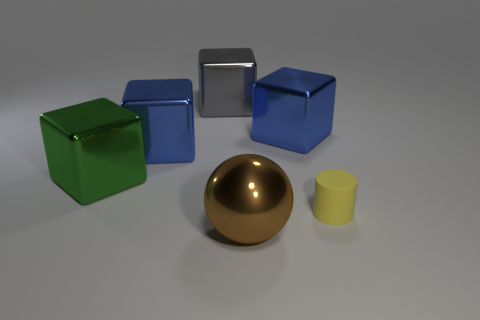Is there a tiny red thing that has the same shape as the green thing? Upon examining the image closely, it appears that there isn’t a tiny red object that matches the shape of the green cube. The items present feature a variety of colors such as green, blue, and golden, along with a silver object and a smaller yellow one, but a tiny red object with a cubical shape is not present. 